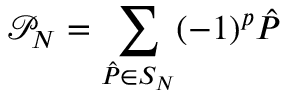Convert formula to latex. <formula><loc_0><loc_0><loc_500><loc_500>\mathcal { P } _ { N } = \sum _ { \hat { P } \in S _ { N } } ( - 1 ) ^ { p } \hat { P }</formula> 